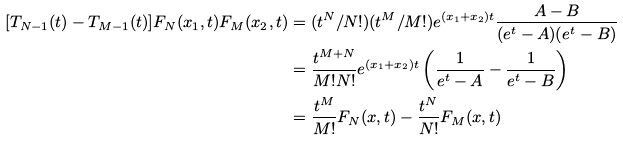<formula> <loc_0><loc_0><loc_500><loc_500>[ T _ { N - 1 } ( t ) - T _ { M - 1 } ( t ) ] F _ { N } ( x _ { 1 } , t ) F _ { M } ( x _ { 2 } , t ) & = ( t ^ { N } / N ! ) ( t ^ { M } / M ! ) e ^ { ( x _ { 1 } + x _ { 2 } ) t } \frac { A - B } { ( e ^ { t } - A ) ( e ^ { t } - B ) } \\ & = \frac { t ^ { M + N } } { M ! N ! } e ^ { ( x _ { 1 } + x _ { 2 } ) t } \left ( \frac { 1 } { e ^ { t } - A } - \frac { 1 } { e ^ { t } - B } \right ) \\ & = \frac { t ^ { M } } { M ! } F _ { N } ( x , t ) - \frac { t ^ { N } } { N ! } F _ { M } ( x , t )</formula> 